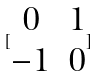Convert formula to latex. <formula><loc_0><loc_0><loc_500><loc_500>[ \begin{matrix} 0 & 1 \\ - 1 & 0 \end{matrix} ]</formula> 